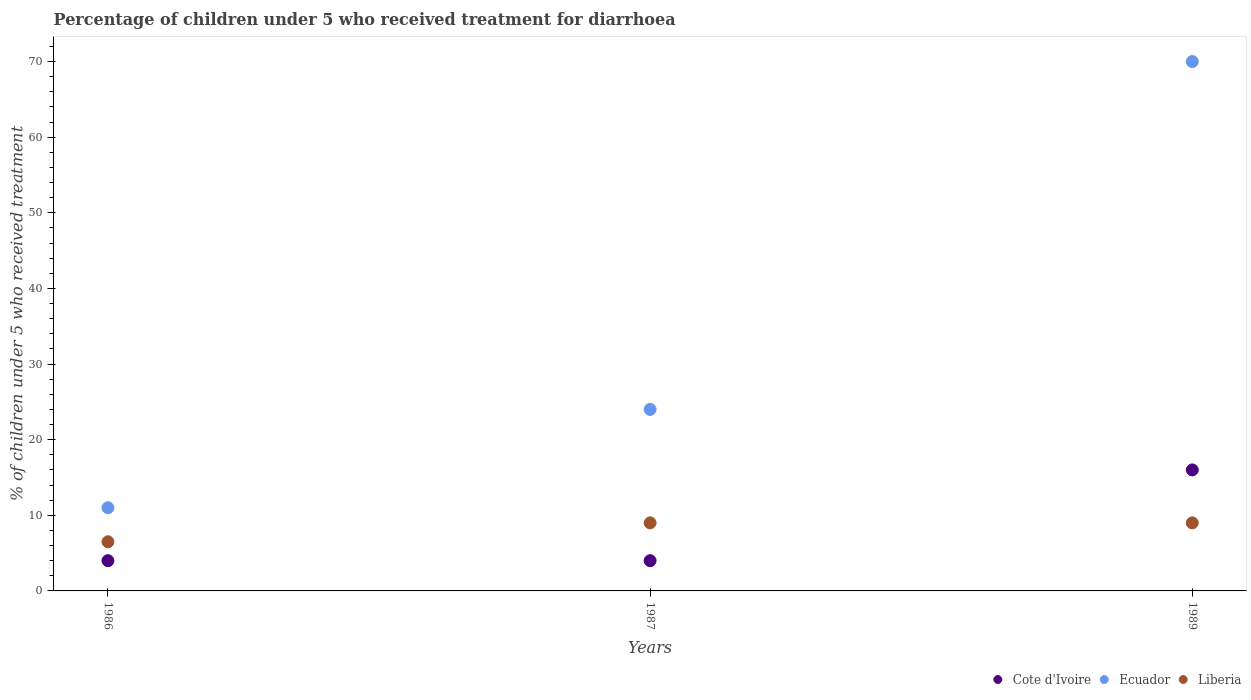How many different coloured dotlines are there?
Your answer should be very brief. 3. Is the number of dotlines equal to the number of legend labels?
Your answer should be compact. Yes. What is the percentage of children who received treatment for diarrhoea  in Cote d'Ivoire in 1986?
Ensure brevity in your answer.  4. In which year was the percentage of children who received treatment for diarrhoea  in Cote d'Ivoire minimum?
Offer a terse response. 1986. What is the total percentage of children who received treatment for diarrhoea  in Ecuador in the graph?
Provide a succinct answer. 105. What is the difference between the percentage of children who received treatment for diarrhoea  in Liberia in 1986 and that in 1987?
Make the answer very short. -2.5. What is the average percentage of children who received treatment for diarrhoea  in Cote d'Ivoire per year?
Provide a short and direct response. 8. In the year 1987, what is the difference between the percentage of children who received treatment for diarrhoea  in Liberia and percentage of children who received treatment for diarrhoea  in Cote d'Ivoire?
Offer a very short reply. 5. In how many years, is the percentage of children who received treatment for diarrhoea  in Ecuador greater than 32 %?
Give a very brief answer. 1. What is the ratio of the percentage of children who received treatment for diarrhoea  in Liberia in 1986 to that in 1987?
Your answer should be compact. 0.72. Is the difference between the percentage of children who received treatment for diarrhoea  in Liberia in 1986 and 1987 greater than the difference between the percentage of children who received treatment for diarrhoea  in Cote d'Ivoire in 1986 and 1987?
Provide a succinct answer. No. What is the difference between the highest and the second highest percentage of children who received treatment for diarrhoea  in Ecuador?
Provide a succinct answer. 46. In how many years, is the percentage of children who received treatment for diarrhoea  in Ecuador greater than the average percentage of children who received treatment for diarrhoea  in Ecuador taken over all years?
Offer a very short reply. 1. Is it the case that in every year, the sum of the percentage of children who received treatment for diarrhoea  in Liberia and percentage of children who received treatment for diarrhoea  in Cote d'Ivoire  is greater than the percentage of children who received treatment for diarrhoea  in Ecuador?
Your response must be concise. No. Does the percentage of children who received treatment for diarrhoea  in Ecuador monotonically increase over the years?
Make the answer very short. Yes. Is the percentage of children who received treatment for diarrhoea  in Liberia strictly greater than the percentage of children who received treatment for diarrhoea  in Ecuador over the years?
Your answer should be compact. No. How many legend labels are there?
Ensure brevity in your answer.  3. How are the legend labels stacked?
Offer a terse response. Horizontal. What is the title of the graph?
Your response must be concise. Percentage of children under 5 who received treatment for diarrhoea. What is the label or title of the Y-axis?
Provide a short and direct response. % of children under 5 who received treatment. What is the % of children under 5 who received treatment in Cote d'Ivoire in 1986?
Ensure brevity in your answer.  4. What is the % of children under 5 who received treatment in Liberia in 1986?
Your response must be concise. 6.5. What is the % of children under 5 who received treatment of Ecuador in 1987?
Ensure brevity in your answer.  24. What is the % of children under 5 who received treatment of Liberia in 1987?
Provide a succinct answer. 9. What is the % of children under 5 who received treatment in Cote d'Ivoire in 1989?
Provide a succinct answer. 16. Across all years, what is the minimum % of children under 5 who received treatment in Liberia?
Keep it short and to the point. 6.5. What is the total % of children under 5 who received treatment of Ecuador in the graph?
Make the answer very short. 105. What is the difference between the % of children under 5 who received treatment in Cote d'Ivoire in 1986 and that in 1987?
Your response must be concise. 0. What is the difference between the % of children under 5 who received treatment of Ecuador in 1986 and that in 1987?
Your response must be concise. -13. What is the difference between the % of children under 5 who received treatment in Liberia in 1986 and that in 1987?
Your answer should be compact. -2.5. What is the difference between the % of children under 5 who received treatment of Cote d'Ivoire in 1986 and that in 1989?
Give a very brief answer. -12. What is the difference between the % of children under 5 who received treatment of Ecuador in 1986 and that in 1989?
Offer a terse response. -59. What is the difference between the % of children under 5 who received treatment in Liberia in 1986 and that in 1989?
Make the answer very short. -2.5. What is the difference between the % of children under 5 who received treatment in Ecuador in 1987 and that in 1989?
Your answer should be very brief. -46. What is the difference between the % of children under 5 who received treatment in Liberia in 1987 and that in 1989?
Give a very brief answer. 0. What is the difference between the % of children under 5 who received treatment in Cote d'Ivoire in 1986 and the % of children under 5 who received treatment in Ecuador in 1987?
Offer a very short reply. -20. What is the difference between the % of children under 5 who received treatment of Cote d'Ivoire in 1986 and the % of children under 5 who received treatment of Liberia in 1987?
Offer a very short reply. -5. What is the difference between the % of children under 5 who received treatment of Cote d'Ivoire in 1986 and the % of children under 5 who received treatment of Ecuador in 1989?
Provide a short and direct response. -66. What is the difference between the % of children under 5 who received treatment in Cote d'Ivoire in 1987 and the % of children under 5 who received treatment in Ecuador in 1989?
Ensure brevity in your answer.  -66. What is the difference between the % of children under 5 who received treatment in Ecuador in 1987 and the % of children under 5 who received treatment in Liberia in 1989?
Your answer should be very brief. 15. What is the average % of children under 5 who received treatment of Ecuador per year?
Provide a succinct answer. 35. What is the average % of children under 5 who received treatment of Liberia per year?
Your response must be concise. 8.17. In the year 1986, what is the difference between the % of children under 5 who received treatment of Cote d'Ivoire and % of children under 5 who received treatment of Ecuador?
Keep it short and to the point. -7. In the year 1986, what is the difference between the % of children under 5 who received treatment of Cote d'Ivoire and % of children under 5 who received treatment of Liberia?
Keep it short and to the point. -2.5. In the year 1986, what is the difference between the % of children under 5 who received treatment in Ecuador and % of children under 5 who received treatment in Liberia?
Give a very brief answer. 4.5. In the year 1987, what is the difference between the % of children under 5 who received treatment of Ecuador and % of children under 5 who received treatment of Liberia?
Your answer should be very brief. 15. In the year 1989, what is the difference between the % of children under 5 who received treatment in Cote d'Ivoire and % of children under 5 who received treatment in Ecuador?
Your answer should be very brief. -54. In the year 1989, what is the difference between the % of children under 5 who received treatment in Cote d'Ivoire and % of children under 5 who received treatment in Liberia?
Ensure brevity in your answer.  7. In the year 1989, what is the difference between the % of children under 5 who received treatment in Ecuador and % of children under 5 who received treatment in Liberia?
Your response must be concise. 61. What is the ratio of the % of children under 5 who received treatment in Ecuador in 1986 to that in 1987?
Give a very brief answer. 0.46. What is the ratio of the % of children under 5 who received treatment in Liberia in 1986 to that in 1987?
Offer a very short reply. 0.72. What is the ratio of the % of children under 5 who received treatment of Ecuador in 1986 to that in 1989?
Your answer should be compact. 0.16. What is the ratio of the % of children under 5 who received treatment in Liberia in 1986 to that in 1989?
Provide a short and direct response. 0.72. What is the ratio of the % of children under 5 who received treatment in Ecuador in 1987 to that in 1989?
Your answer should be compact. 0.34. What is the ratio of the % of children under 5 who received treatment in Liberia in 1987 to that in 1989?
Offer a terse response. 1. What is the difference between the highest and the second highest % of children under 5 who received treatment in Cote d'Ivoire?
Your answer should be very brief. 12. What is the difference between the highest and the second highest % of children under 5 who received treatment of Ecuador?
Offer a terse response. 46. What is the difference between the highest and the second highest % of children under 5 who received treatment of Liberia?
Make the answer very short. 0. What is the difference between the highest and the lowest % of children under 5 who received treatment of Cote d'Ivoire?
Offer a terse response. 12. What is the difference between the highest and the lowest % of children under 5 who received treatment of Ecuador?
Ensure brevity in your answer.  59. 